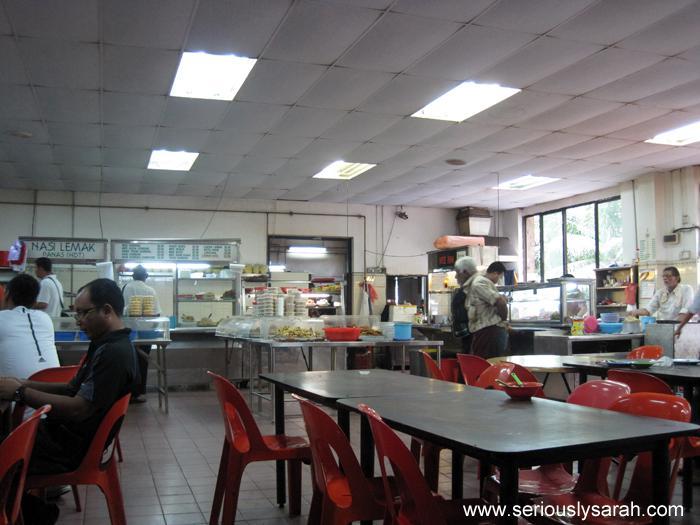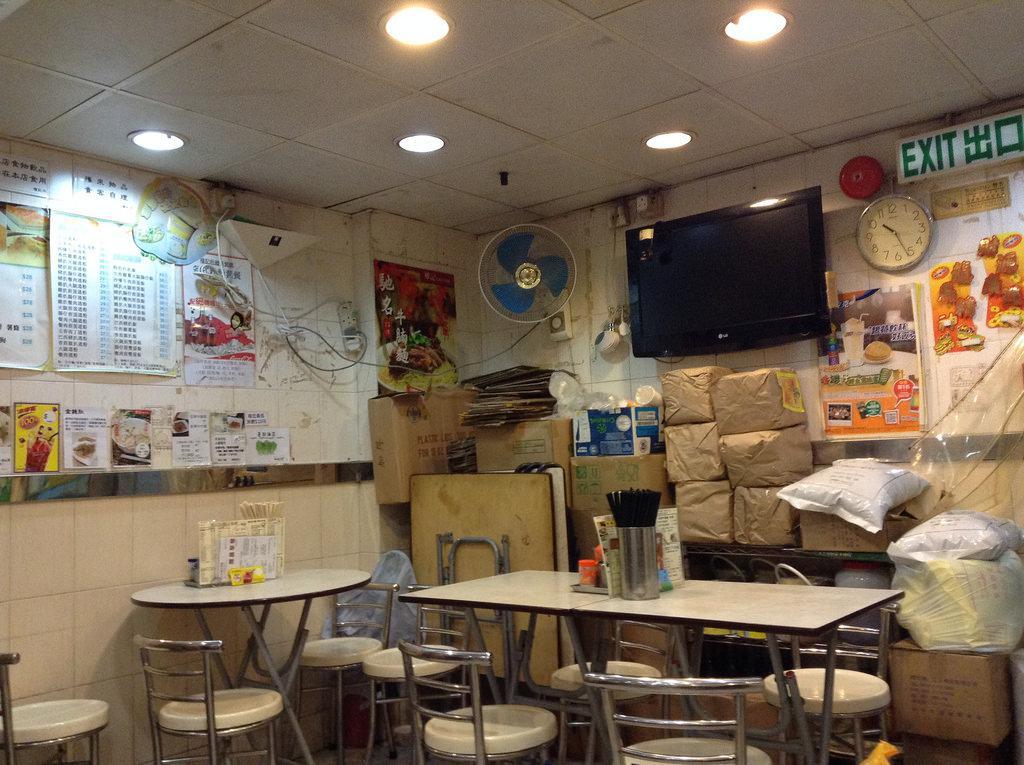The first image is the image on the left, the second image is the image on the right. Examine the images to the left and right. Is the description "One image has windows and the other does not." accurate? Answer yes or no. Yes. The first image is the image on the left, the second image is the image on the right. Examine the images to the left and right. Is the description "People are standing at the counter of the restaurant in one of the images." accurate? Answer yes or no. Yes. 